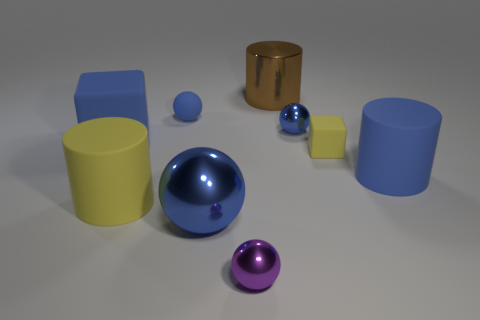What is the material of the cylinder that is the same color as the large matte block?
Your answer should be very brief. Rubber. Is there a large blue thing that is to the right of the blue rubber object that is behind the blue block?
Ensure brevity in your answer.  Yes. Is the number of large brown cylinders less than the number of big blue metal cubes?
Ensure brevity in your answer.  No. How many tiny purple metallic objects are the same shape as the small blue metal thing?
Provide a short and direct response. 1. What number of blue objects are large shiny balls or rubber blocks?
Offer a terse response. 2. How big is the yellow rubber object in front of the rubber cylinder that is to the right of the tiny blue matte sphere?
Offer a terse response. Large. There is a blue object that is the same shape as the big brown metal thing; what material is it?
Ensure brevity in your answer.  Rubber. How many other cylinders have the same size as the brown cylinder?
Offer a terse response. 2. Does the blue matte cylinder have the same size as the blue rubber block?
Your answer should be very brief. Yes. There is a metallic object that is behind the big blue rubber cylinder and in front of the brown metal cylinder; what size is it?
Ensure brevity in your answer.  Small. 